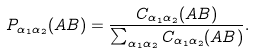Convert formula to latex. <formula><loc_0><loc_0><loc_500><loc_500>P _ { \alpha _ { 1 } \alpha _ { 2 } } ( A B ) = \frac { C _ { \alpha _ { 1 } \alpha _ { 2 } } ( A B ) } { \sum _ { \alpha _ { 1 } \alpha _ { 2 } } C _ { \alpha _ { 1 } \alpha _ { 2 } } ( A B ) } .</formula> 